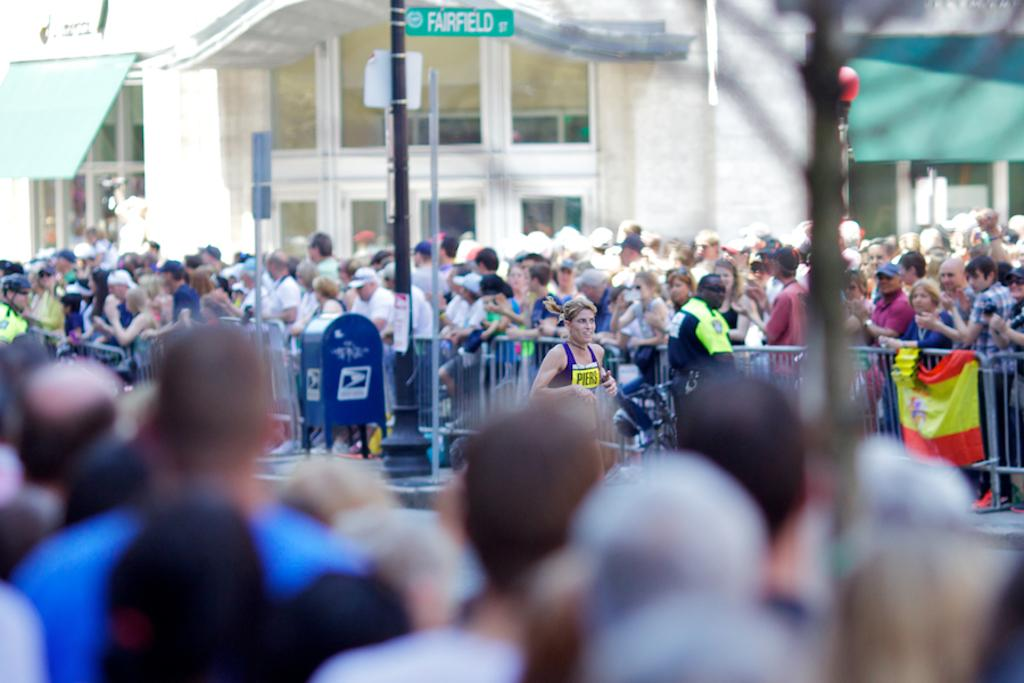How many people can be seen in the image? There are many people in the image. What are the people in the image doing? The people are watching a running race. What structures can be seen in the image? There are buildings in the image. What objects are present in the image that are related to the race? There are poles and flags in the image. What type of barrier is visible in the image? There is a fence visible in the image. What type of vessel is being used for observation during the race? There is no vessel present in the image; it is a land-based event with people watching from the sidelines. 